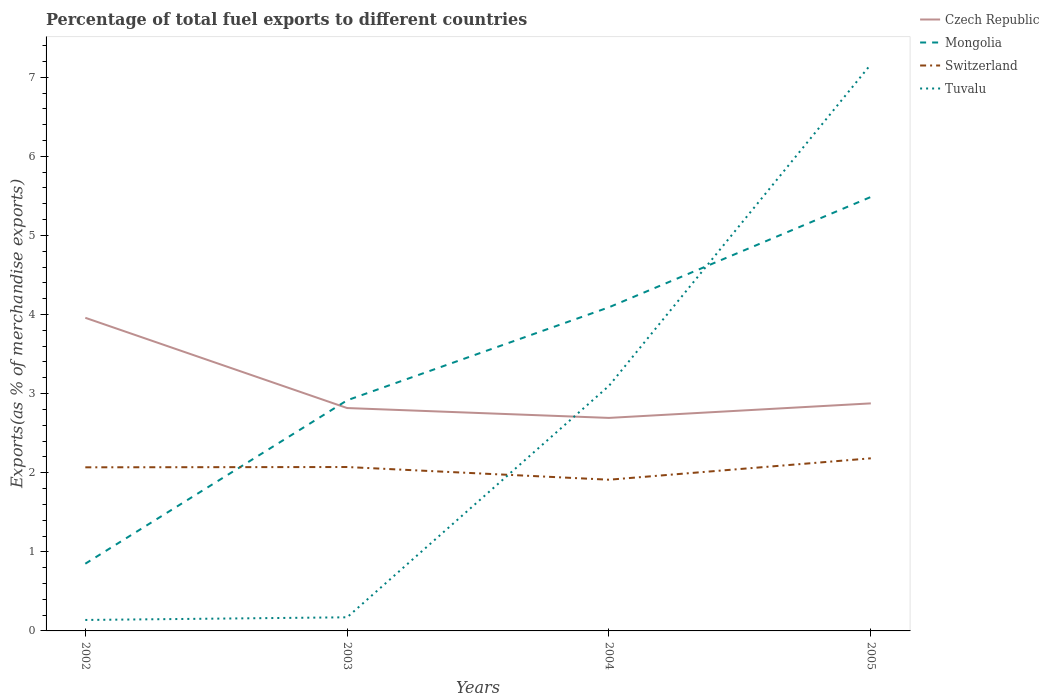How many different coloured lines are there?
Ensure brevity in your answer.  4. Does the line corresponding to Switzerland intersect with the line corresponding to Tuvalu?
Offer a terse response. Yes. Across all years, what is the maximum percentage of exports to different countries in Czech Republic?
Provide a short and direct response. 2.69. What is the total percentage of exports to different countries in Tuvalu in the graph?
Your answer should be very brief. -2.96. What is the difference between the highest and the second highest percentage of exports to different countries in Switzerland?
Ensure brevity in your answer.  0.27. Is the percentage of exports to different countries in Tuvalu strictly greater than the percentage of exports to different countries in Mongolia over the years?
Provide a succinct answer. No. How many lines are there?
Your answer should be very brief. 4. How many years are there in the graph?
Offer a very short reply. 4. What is the difference between two consecutive major ticks on the Y-axis?
Make the answer very short. 1. Does the graph contain grids?
Ensure brevity in your answer.  No. Where does the legend appear in the graph?
Provide a succinct answer. Top right. How are the legend labels stacked?
Your answer should be compact. Vertical. What is the title of the graph?
Your answer should be very brief. Percentage of total fuel exports to different countries. What is the label or title of the Y-axis?
Give a very brief answer. Exports(as % of merchandise exports). What is the Exports(as % of merchandise exports) of Czech Republic in 2002?
Ensure brevity in your answer.  3.96. What is the Exports(as % of merchandise exports) in Mongolia in 2002?
Your answer should be very brief. 0.85. What is the Exports(as % of merchandise exports) of Switzerland in 2002?
Your answer should be very brief. 2.07. What is the Exports(as % of merchandise exports) of Tuvalu in 2002?
Your answer should be compact. 0.14. What is the Exports(as % of merchandise exports) in Czech Republic in 2003?
Ensure brevity in your answer.  2.82. What is the Exports(as % of merchandise exports) in Mongolia in 2003?
Ensure brevity in your answer.  2.92. What is the Exports(as % of merchandise exports) in Switzerland in 2003?
Keep it short and to the point. 2.07. What is the Exports(as % of merchandise exports) in Tuvalu in 2003?
Provide a short and direct response. 0.17. What is the Exports(as % of merchandise exports) of Czech Republic in 2004?
Keep it short and to the point. 2.69. What is the Exports(as % of merchandise exports) of Mongolia in 2004?
Ensure brevity in your answer.  4.09. What is the Exports(as % of merchandise exports) in Switzerland in 2004?
Your response must be concise. 1.91. What is the Exports(as % of merchandise exports) in Tuvalu in 2004?
Make the answer very short. 3.1. What is the Exports(as % of merchandise exports) in Czech Republic in 2005?
Offer a very short reply. 2.88. What is the Exports(as % of merchandise exports) of Mongolia in 2005?
Offer a very short reply. 5.49. What is the Exports(as % of merchandise exports) in Switzerland in 2005?
Provide a succinct answer. 2.18. What is the Exports(as % of merchandise exports) of Tuvalu in 2005?
Your response must be concise. 7.16. Across all years, what is the maximum Exports(as % of merchandise exports) in Czech Republic?
Offer a terse response. 3.96. Across all years, what is the maximum Exports(as % of merchandise exports) of Mongolia?
Provide a succinct answer. 5.49. Across all years, what is the maximum Exports(as % of merchandise exports) of Switzerland?
Your answer should be compact. 2.18. Across all years, what is the maximum Exports(as % of merchandise exports) in Tuvalu?
Your response must be concise. 7.16. Across all years, what is the minimum Exports(as % of merchandise exports) in Czech Republic?
Make the answer very short. 2.69. Across all years, what is the minimum Exports(as % of merchandise exports) of Mongolia?
Your answer should be very brief. 0.85. Across all years, what is the minimum Exports(as % of merchandise exports) of Switzerland?
Keep it short and to the point. 1.91. Across all years, what is the minimum Exports(as % of merchandise exports) in Tuvalu?
Your answer should be compact. 0.14. What is the total Exports(as % of merchandise exports) of Czech Republic in the graph?
Make the answer very short. 12.35. What is the total Exports(as % of merchandise exports) of Mongolia in the graph?
Ensure brevity in your answer.  13.34. What is the total Exports(as % of merchandise exports) in Switzerland in the graph?
Ensure brevity in your answer.  8.23. What is the total Exports(as % of merchandise exports) in Tuvalu in the graph?
Your response must be concise. 10.57. What is the difference between the Exports(as % of merchandise exports) of Czech Republic in 2002 and that in 2003?
Give a very brief answer. 1.14. What is the difference between the Exports(as % of merchandise exports) of Mongolia in 2002 and that in 2003?
Ensure brevity in your answer.  -2.07. What is the difference between the Exports(as % of merchandise exports) in Switzerland in 2002 and that in 2003?
Your answer should be very brief. -0. What is the difference between the Exports(as % of merchandise exports) of Tuvalu in 2002 and that in 2003?
Ensure brevity in your answer.  -0.03. What is the difference between the Exports(as % of merchandise exports) in Czech Republic in 2002 and that in 2004?
Offer a terse response. 1.27. What is the difference between the Exports(as % of merchandise exports) in Mongolia in 2002 and that in 2004?
Your response must be concise. -3.24. What is the difference between the Exports(as % of merchandise exports) of Switzerland in 2002 and that in 2004?
Offer a very short reply. 0.16. What is the difference between the Exports(as % of merchandise exports) of Tuvalu in 2002 and that in 2004?
Offer a terse response. -2.96. What is the difference between the Exports(as % of merchandise exports) in Czech Republic in 2002 and that in 2005?
Your answer should be compact. 1.08. What is the difference between the Exports(as % of merchandise exports) in Mongolia in 2002 and that in 2005?
Your answer should be very brief. -4.64. What is the difference between the Exports(as % of merchandise exports) of Switzerland in 2002 and that in 2005?
Offer a terse response. -0.11. What is the difference between the Exports(as % of merchandise exports) in Tuvalu in 2002 and that in 2005?
Make the answer very short. -7.02. What is the difference between the Exports(as % of merchandise exports) in Czech Republic in 2003 and that in 2004?
Give a very brief answer. 0.12. What is the difference between the Exports(as % of merchandise exports) in Mongolia in 2003 and that in 2004?
Your answer should be very brief. -1.18. What is the difference between the Exports(as % of merchandise exports) in Switzerland in 2003 and that in 2004?
Your response must be concise. 0.16. What is the difference between the Exports(as % of merchandise exports) in Tuvalu in 2003 and that in 2004?
Give a very brief answer. -2.93. What is the difference between the Exports(as % of merchandise exports) of Czech Republic in 2003 and that in 2005?
Provide a short and direct response. -0.06. What is the difference between the Exports(as % of merchandise exports) of Mongolia in 2003 and that in 2005?
Ensure brevity in your answer.  -2.57. What is the difference between the Exports(as % of merchandise exports) in Switzerland in 2003 and that in 2005?
Keep it short and to the point. -0.11. What is the difference between the Exports(as % of merchandise exports) in Tuvalu in 2003 and that in 2005?
Make the answer very short. -6.99. What is the difference between the Exports(as % of merchandise exports) of Czech Republic in 2004 and that in 2005?
Your response must be concise. -0.18. What is the difference between the Exports(as % of merchandise exports) of Mongolia in 2004 and that in 2005?
Give a very brief answer. -1.39. What is the difference between the Exports(as % of merchandise exports) of Switzerland in 2004 and that in 2005?
Your answer should be compact. -0.27. What is the difference between the Exports(as % of merchandise exports) in Tuvalu in 2004 and that in 2005?
Offer a very short reply. -4.06. What is the difference between the Exports(as % of merchandise exports) in Czech Republic in 2002 and the Exports(as % of merchandise exports) in Mongolia in 2003?
Your answer should be very brief. 1.04. What is the difference between the Exports(as % of merchandise exports) in Czech Republic in 2002 and the Exports(as % of merchandise exports) in Switzerland in 2003?
Offer a very short reply. 1.89. What is the difference between the Exports(as % of merchandise exports) of Czech Republic in 2002 and the Exports(as % of merchandise exports) of Tuvalu in 2003?
Your response must be concise. 3.79. What is the difference between the Exports(as % of merchandise exports) of Mongolia in 2002 and the Exports(as % of merchandise exports) of Switzerland in 2003?
Provide a short and direct response. -1.22. What is the difference between the Exports(as % of merchandise exports) of Mongolia in 2002 and the Exports(as % of merchandise exports) of Tuvalu in 2003?
Keep it short and to the point. 0.68. What is the difference between the Exports(as % of merchandise exports) of Switzerland in 2002 and the Exports(as % of merchandise exports) of Tuvalu in 2003?
Keep it short and to the point. 1.9. What is the difference between the Exports(as % of merchandise exports) in Czech Republic in 2002 and the Exports(as % of merchandise exports) in Mongolia in 2004?
Ensure brevity in your answer.  -0.13. What is the difference between the Exports(as % of merchandise exports) in Czech Republic in 2002 and the Exports(as % of merchandise exports) in Switzerland in 2004?
Provide a succinct answer. 2.05. What is the difference between the Exports(as % of merchandise exports) in Czech Republic in 2002 and the Exports(as % of merchandise exports) in Tuvalu in 2004?
Your response must be concise. 0.86. What is the difference between the Exports(as % of merchandise exports) of Mongolia in 2002 and the Exports(as % of merchandise exports) of Switzerland in 2004?
Your response must be concise. -1.06. What is the difference between the Exports(as % of merchandise exports) in Mongolia in 2002 and the Exports(as % of merchandise exports) in Tuvalu in 2004?
Ensure brevity in your answer.  -2.25. What is the difference between the Exports(as % of merchandise exports) of Switzerland in 2002 and the Exports(as % of merchandise exports) of Tuvalu in 2004?
Your answer should be very brief. -1.03. What is the difference between the Exports(as % of merchandise exports) in Czech Republic in 2002 and the Exports(as % of merchandise exports) in Mongolia in 2005?
Give a very brief answer. -1.53. What is the difference between the Exports(as % of merchandise exports) of Czech Republic in 2002 and the Exports(as % of merchandise exports) of Switzerland in 2005?
Your answer should be compact. 1.78. What is the difference between the Exports(as % of merchandise exports) of Czech Republic in 2002 and the Exports(as % of merchandise exports) of Tuvalu in 2005?
Keep it short and to the point. -3.2. What is the difference between the Exports(as % of merchandise exports) in Mongolia in 2002 and the Exports(as % of merchandise exports) in Switzerland in 2005?
Provide a succinct answer. -1.33. What is the difference between the Exports(as % of merchandise exports) of Mongolia in 2002 and the Exports(as % of merchandise exports) of Tuvalu in 2005?
Provide a short and direct response. -6.31. What is the difference between the Exports(as % of merchandise exports) in Switzerland in 2002 and the Exports(as % of merchandise exports) in Tuvalu in 2005?
Offer a very short reply. -5.09. What is the difference between the Exports(as % of merchandise exports) in Czech Republic in 2003 and the Exports(as % of merchandise exports) in Mongolia in 2004?
Make the answer very short. -1.27. What is the difference between the Exports(as % of merchandise exports) in Czech Republic in 2003 and the Exports(as % of merchandise exports) in Switzerland in 2004?
Your answer should be very brief. 0.91. What is the difference between the Exports(as % of merchandise exports) of Czech Republic in 2003 and the Exports(as % of merchandise exports) of Tuvalu in 2004?
Offer a terse response. -0.28. What is the difference between the Exports(as % of merchandise exports) in Mongolia in 2003 and the Exports(as % of merchandise exports) in Switzerland in 2004?
Offer a very short reply. 1. What is the difference between the Exports(as % of merchandise exports) in Mongolia in 2003 and the Exports(as % of merchandise exports) in Tuvalu in 2004?
Offer a very short reply. -0.18. What is the difference between the Exports(as % of merchandise exports) in Switzerland in 2003 and the Exports(as % of merchandise exports) in Tuvalu in 2004?
Offer a very short reply. -1.03. What is the difference between the Exports(as % of merchandise exports) in Czech Republic in 2003 and the Exports(as % of merchandise exports) in Mongolia in 2005?
Make the answer very short. -2.67. What is the difference between the Exports(as % of merchandise exports) of Czech Republic in 2003 and the Exports(as % of merchandise exports) of Switzerland in 2005?
Your answer should be compact. 0.64. What is the difference between the Exports(as % of merchandise exports) of Czech Republic in 2003 and the Exports(as % of merchandise exports) of Tuvalu in 2005?
Give a very brief answer. -4.35. What is the difference between the Exports(as % of merchandise exports) of Mongolia in 2003 and the Exports(as % of merchandise exports) of Switzerland in 2005?
Make the answer very short. 0.73. What is the difference between the Exports(as % of merchandise exports) in Mongolia in 2003 and the Exports(as % of merchandise exports) in Tuvalu in 2005?
Offer a terse response. -4.25. What is the difference between the Exports(as % of merchandise exports) in Switzerland in 2003 and the Exports(as % of merchandise exports) in Tuvalu in 2005?
Give a very brief answer. -5.09. What is the difference between the Exports(as % of merchandise exports) of Czech Republic in 2004 and the Exports(as % of merchandise exports) of Mongolia in 2005?
Offer a terse response. -2.79. What is the difference between the Exports(as % of merchandise exports) in Czech Republic in 2004 and the Exports(as % of merchandise exports) in Switzerland in 2005?
Give a very brief answer. 0.51. What is the difference between the Exports(as % of merchandise exports) in Czech Republic in 2004 and the Exports(as % of merchandise exports) in Tuvalu in 2005?
Ensure brevity in your answer.  -4.47. What is the difference between the Exports(as % of merchandise exports) in Mongolia in 2004 and the Exports(as % of merchandise exports) in Switzerland in 2005?
Your answer should be compact. 1.91. What is the difference between the Exports(as % of merchandise exports) of Mongolia in 2004 and the Exports(as % of merchandise exports) of Tuvalu in 2005?
Provide a short and direct response. -3.07. What is the difference between the Exports(as % of merchandise exports) of Switzerland in 2004 and the Exports(as % of merchandise exports) of Tuvalu in 2005?
Offer a very short reply. -5.25. What is the average Exports(as % of merchandise exports) of Czech Republic per year?
Offer a terse response. 3.09. What is the average Exports(as % of merchandise exports) in Mongolia per year?
Keep it short and to the point. 3.34. What is the average Exports(as % of merchandise exports) of Switzerland per year?
Make the answer very short. 2.06. What is the average Exports(as % of merchandise exports) of Tuvalu per year?
Give a very brief answer. 2.64. In the year 2002, what is the difference between the Exports(as % of merchandise exports) of Czech Republic and Exports(as % of merchandise exports) of Mongolia?
Keep it short and to the point. 3.11. In the year 2002, what is the difference between the Exports(as % of merchandise exports) of Czech Republic and Exports(as % of merchandise exports) of Switzerland?
Make the answer very short. 1.89. In the year 2002, what is the difference between the Exports(as % of merchandise exports) of Czech Republic and Exports(as % of merchandise exports) of Tuvalu?
Ensure brevity in your answer.  3.82. In the year 2002, what is the difference between the Exports(as % of merchandise exports) of Mongolia and Exports(as % of merchandise exports) of Switzerland?
Keep it short and to the point. -1.22. In the year 2002, what is the difference between the Exports(as % of merchandise exports) of Mongolia and Exports(as % of merchandise exports) of Tuvalu?
Keep it short and to the point. 0.71. In the year 2002, what is the difference between the Exports(as % of merchandise exports) in Switzerland and Exports(as % of merchandise exports) in Tuvalu?
Offer a very short reply. 1.93. In the year 2003, what is the difference between the Exports(as % of merchandise exports) of Czech Republic and Exports(as % of merchandise exports) of Mongolia?
Your answer should be compact. -0.1. In the year 2003, what is the difference between the Exports(as % of merchandise exports) of Czech Republic and Exports(as % of merchandise exports) of Switzerland?
Offer a very short reply. 0.75. In the year 2003, what is the difference between the Exports(as % of merchandise exports) in Czech Republic and Exports(as % of merchandise exports) in Tuvalu?
Ensure brevity in your answer.  2.65. In the year 2003, what is the difference between the Exports(as % of merchandise exports) in Mongolia and Exports(as % of merchandise exports) in Switzerland?
Offer a terse response. 0.84. In the year 2003, what is the difference between the Exports(as % of merchandise exports) of Mongolia and Exports(as % of merchandise exports) of Tuvalu?
Your response must be concise. 2.74. In the year 2003, what is the difference between the Exports(as % of merchandise exports) in Switzerland and Exports(as % of merchandise exports) in Tuvalu?
Offer a terse response. 1.9. In the year 2004, what is the difference between the Exports(as % of merchandise exports) of Czech Republic and Exports(as % of merchandise exports) of Mongolia?
Your response must be concise. -1.4. In the year 2004, what is the difference between the Exports(as % of merchandise exports) of Czech Republic and Exports(as % of merchandise exports) of Switzerland?
Your answer should be compact. 0.78. In the year 2004, what is the difference between the Exports(as % of merchandise exports) of Czech Republic and Exports(as % of merchandise exports) of Tuvalu?
Your response must be concise. -0.41. In the year 2004, what is the difference between the Exports(as % of merchandise exports) of Mongolia and Exports(as % of merchandise exports) of Switzerland?
Provide a short and direct response. 2.18. In the year 2004, what is the difference between the Exports(as % of merchandise exports) of Mongolia and Exports(as % of merchandise exports) of Tuvalu?
Give a very brief answer. 0.99. In the year 2004, what is the difference between the Exports(as % of merchandise exports) in Switzerland and Exports(as % of merchandise exports) in Tuvalu?
Provide a short and direct response. -1.19. In the year 2005, what is the difference between the Exports(as % of merchandise exports) in Czech Republic and Exports(as % of merchandise exports) in Mongolia?
Provide a succinct answer. -2.61. In the year 2005, what is the difference between the Exports(as % of merchandise exports) in Czech Republic and Exports(as % of merchandise exports) in Switzerland?
Offer a terse response. 0.69. In the year 2005, what is the difference between the Exports(as % of merchandise exports) in Czech Republic and Exports(as % of merchandise exports) in Tuvalu?
Ensure brevity in your answer.  -4.29. In the year 2005, what is the difference between the Exports(as % of merchandise exports) in Mongolia and Exports(as % of merchandise exports) in Switzerland?
Offer a very short reply. 3.3. In the year 2005, what is the difference between the Exports(as % of merchandise exports) of Mongolia and Exports(as % of merchandise exports) of Tuvalu?
Ensure brevity in your answer.  -1.68. In the year 2005, what is the difference between the Exports(as % of merchandise exports) of Switzerland and Exports(as % of merchandise exports) of Tuvalu?
Provide a short and direct response. -4.98. What is the ratio of the Exports(as % of merchandise exports) of Czech Republic in 2002 to that in 2003?
Your response must be concise. 1.41. What is the ratio of the Exports(as % of merchandise exports) in Mongolia in 2002 to that in 2003?
Give a very brief answer. 0.29. What is the ratio of the Exports(as % of merchandise exports) of Tuvalu in 2002 to that in 2003?
Your answer should be very brief. 0.8. What is the ratio of the Exports(as % of merchandise exports) in Czech Republic in 2002 to that in 2004?
Offer a terse response. 1.47. What is the ratio of the Exports(as % of merchandise exports) of Mongolia in 2002 to that in 2004?
Ensure brevity in your answer.  0.21. What is the ratio of the Exports(as % of merchandise exports) in Switzerland in 2002 to that in 2004?
Your answer should be compact. 1.08. What is the ratio of the Exports(as % of merchandise exports) in Tuvalu in 2002 to that in 2004?
Provide a succinct answer. 0.04. What is the ratio of the Exports(as % of merchandise exports) of Czech Republic in 2002 to that in 2005?
Your answer should be very brief. 1.38. What is the ratio of the Exports(as % of merchandise exports) in Mongolia in 2002 to that in 2005?
Give a very brief answer. 0.15. What is the ratio of the Exports(as % of merchandise exports) in Switzerland in 2002 to that in 2005?
Offer a very short reply. 0.95. What is the ratio of the Exports(as % of merchandise exports) in Tuvalu in 2002 to that in 2005?
Your answer should be compact. 0.02. What is the ratio of the Exports(as % of merchandise exports) in Czech Republic in 2003 to that in 2004?
Provide a succinct answer. 1.05. What is the ratio of the Exports(as % of merchandise exports) in Mongolia in 2003 to that in 2004?
Provide a short and direct response. 0.71. What is the ratio of the Exports(as % of merchandise exports) of Switzerland in 2003 to that in 2004?
Provide a short and direct response. 1.08. What is the ratio of the Exports(as % of merchandise exports) in Tuvalu in 2003 to that in 2004?
Offer a very short reply. 0.06. What is the ratio of the Exports(as % of merchandise exports) of Czech Republic in 2003 to that in 2005?
Offer a terse response. 0.98. What is the ratio of the Exports(as % of merchandise exports) in Mongolia in 2003 to that in 2005?
Offer a very short reply. 0.53. What is the ratio of the Exports(as % of merchandise exports) of Switzerland in 2003 to that in 2005?
Make the answer very short. 0.95. What is the ratio of the Exports(as % of merchandise exports) of Tuvalu in 2003 to that in 2005?
Keep it short and to the point. 0.02. What is the ratio of the Exports(as % of merchandise exports) in Czech Republic in 2004 to that in 2005?
Make the answer very short. 0.94. What is the ratio of the Exports(as % of merchandise exports) in Mongolia in 2004 to that in 2005?
Your answer should be very brief. 0.75. What is the ratio of the Exports(as % of merchandise exports) of Switzerland in 2004 to that in 2005?
Provide a succinct answer. 0.88. What is the ratio of the Exports(as % of merchandise exports) of Tuvalu in 2004 to that in 2005?
Offer a very short reply. 0.43. What is the difference between the highest and the second highest Exports(as % of merchandise exports) in Czech Republic?
Your answer should be compact. 1.08. What is the difference between the highest and the second highest Exports(as % of merchandise exports) in Mongolia?
Provide a succinct answer. 1.39. What is the difference between the highest and the second highest Exports(as % of merchandise exports) in Switzerland?
Make the answer very short. 0.11. What is the difference between the highest and the second highest Exports(as % of merchandise exports) of Tuvalu?
Provide a succinct answer. 4.06. What is the difference between the highest and the lowest Exports(as % of merchandise exports) in Czech Republic?
Your response must be concise. 1.27. What is the difference between the highest and the lowest Exports(as % of merchandise exports) of Mongolia?
Provide a short and direct response. 4.64. What is the difference between the highest and the lowest Exports(as % of merchandise exports) of Switzerland?
Your response must be concise. 0.27. What is the difference between the highest and the lowest Exports(as % of merchandise exports) of Tuvalu?
Offer a terse response. 7.02. 